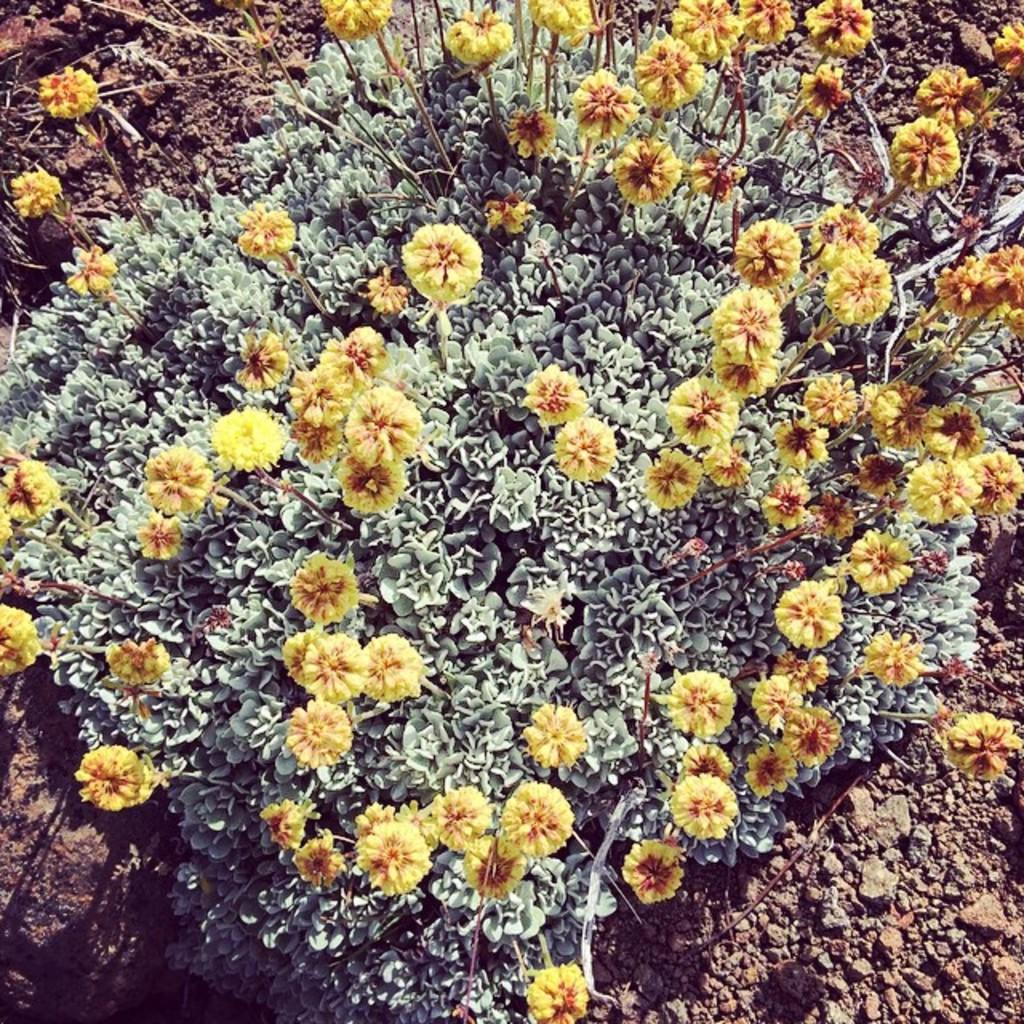What type of plants can be seen in the image? There are plants with flowers in the image. What is the base material for the plants in the image? There is soil visible in the image. What type of letter is the spy sending from the location in the image? There is no spy or letter present in the image; it features plants with flowers and soil. 